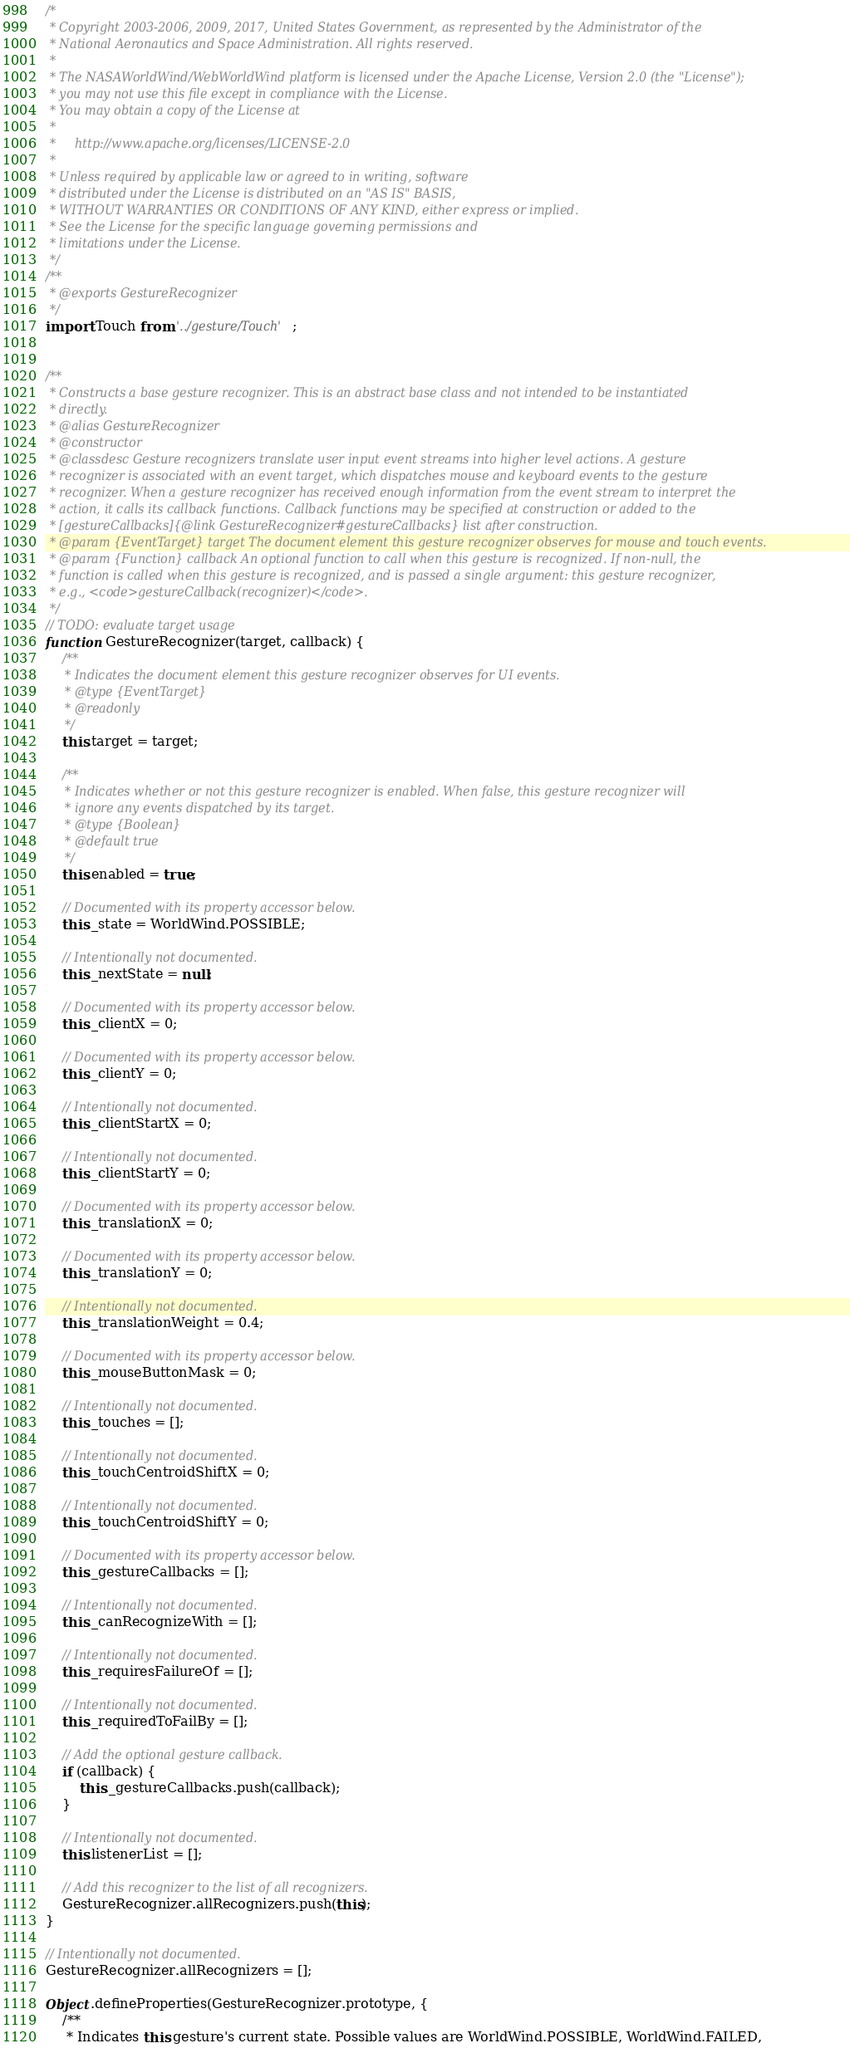Convert code to text. <code><loc_0><loc_0><loc_500><loc_500><_JavaScript_>/*
 * Copyright 2003-2006, 2009, 2017, United States Government, as represented by the Administrator of the
 * National Aeronautics and Space Administration. All rights reserved.
 *
 * The NASAWorldWind/WebWorldWind platform is licensed under the Apache License, Version 2.0 (the "License");
 * you may not use this file except in compliance with the License.
 * You may obtain a copy of the License at
 *
 *     http://www.apache.org/licenses/LICENSE-2.0
 *
 * Unless required by applicable law or agreed to in writing, software
 * distributed under the License is distributed on an "AS IS" BASIS,
 * WITHOUT WARRANTIES OR CONDITIONS OF ANY KIND, either express or implied.
 * See the License for the specific language governing permissions and
 * limitations under the License.
 */
/**
 * @exports GestureRecognizer
 */
import Touch from '../gesture/Touch';


/**
 * Constructs a base gesture recognizer. This is an abstract base class and not intended to be instantiated
 * directly.
 * @alias GestureRecognizer
 * @constructor
 * @classdesc Gesture recognizers translate user input event streams into higher level actions. A gesture
 * recognizer is associated with an event target, which dispatches mouse and keyboard events to the gesture
 * recognizer. When a gesture recognizer has received enough information from the event stream to interpret the
 * action, it calls its callback functions. Callback functions may be specified at construction or added to the
 * [gestureCallbacks]{@link GestureRecognizer#gestureCallbacks} list after construction.
 * @param {EventTarget} target The document element this gesture recognizer observes for mouse and touch events.
 * @param {Function} callback An optional function to call when this gesture is recognized. If non-null, the
 * function is called when this gesture is recognized, and is passed a single argument: this gesture recognizer,
 * e.g., <code>gestureCallback(recognizer)</code>.
 */
// TODO: evaluate target usage
function GestureRecognizer(target, callback) {
    /**
     * Indicates the document element this gesture recognizer observes for UI events.
     * @type {EventTarget}
     * @readonly
     */
    this.target = target;

    /**
     * Indicates whether or not this gesture recognizer is enabled. When false, this gesture recognizer will
     * ignore any events dispatched by its target.
     * @type {Boolean}
     * @default true
     */
    this.enabled = true;

    // Documented with its property accessor below.
    this._state = WorldWind.POSSIBLE;

    // Intentionally not documented.
    this._nextState = null;

    // Documented with its property accessor below.
    this._clientX = 0;

    // Documented with its property accessor below.
    this._clientY = 0;

    // Intentionally not documented.
    this._clientStartX = 0;

    // Intentionally not documented.
    this._clientStartY = 0;

    // Documented with its property accessor below.
    this._translationX = 0;

    // Documented with its property accessor below.
    this._translationY = 0;

    // Intentionally not documented.
    this._translationWeight = 0.4;

    // Documented with its property accessor below.
    this._mouseButtonMask = 0;

    // Intentionally not documented.
    this._touches = [];

    // Intentionally not documented.
    this._touchCentroidShiftX = 0;

    // Intentionally not documented.
    this._touchCentroidShiftY = 0;

    // Documented with its property accessor below.
    this._gestureCallbacks = [];

    // Intentionally not documented.
    this._canRecognizeWith = [];

    // Intentionally not documented.
    this._requiresFailureOf = [];

    // Intentionally not documented.
    this._requiredToFailBy = [];

    // Add the optional gesture callback.
    if (callback) {
        this._gestureCallbacks.push(callback);
    }

    // Intentionally not documented.
    this.listenerList = [];

    // Add this recognizer to the list of all recognizers.
    GestureRecognizer.allRecognizers.push(this);
}

// Intentionally not documented.
GestureRecognizer.allRecognizers = [];

Object.defineProperties(GestureRecognizer.prototype, {
    /**
     * Indicates this gesture's current state. Possible values are WorldWind.POSSIBLE, WorldWind.FAILED,</code> 